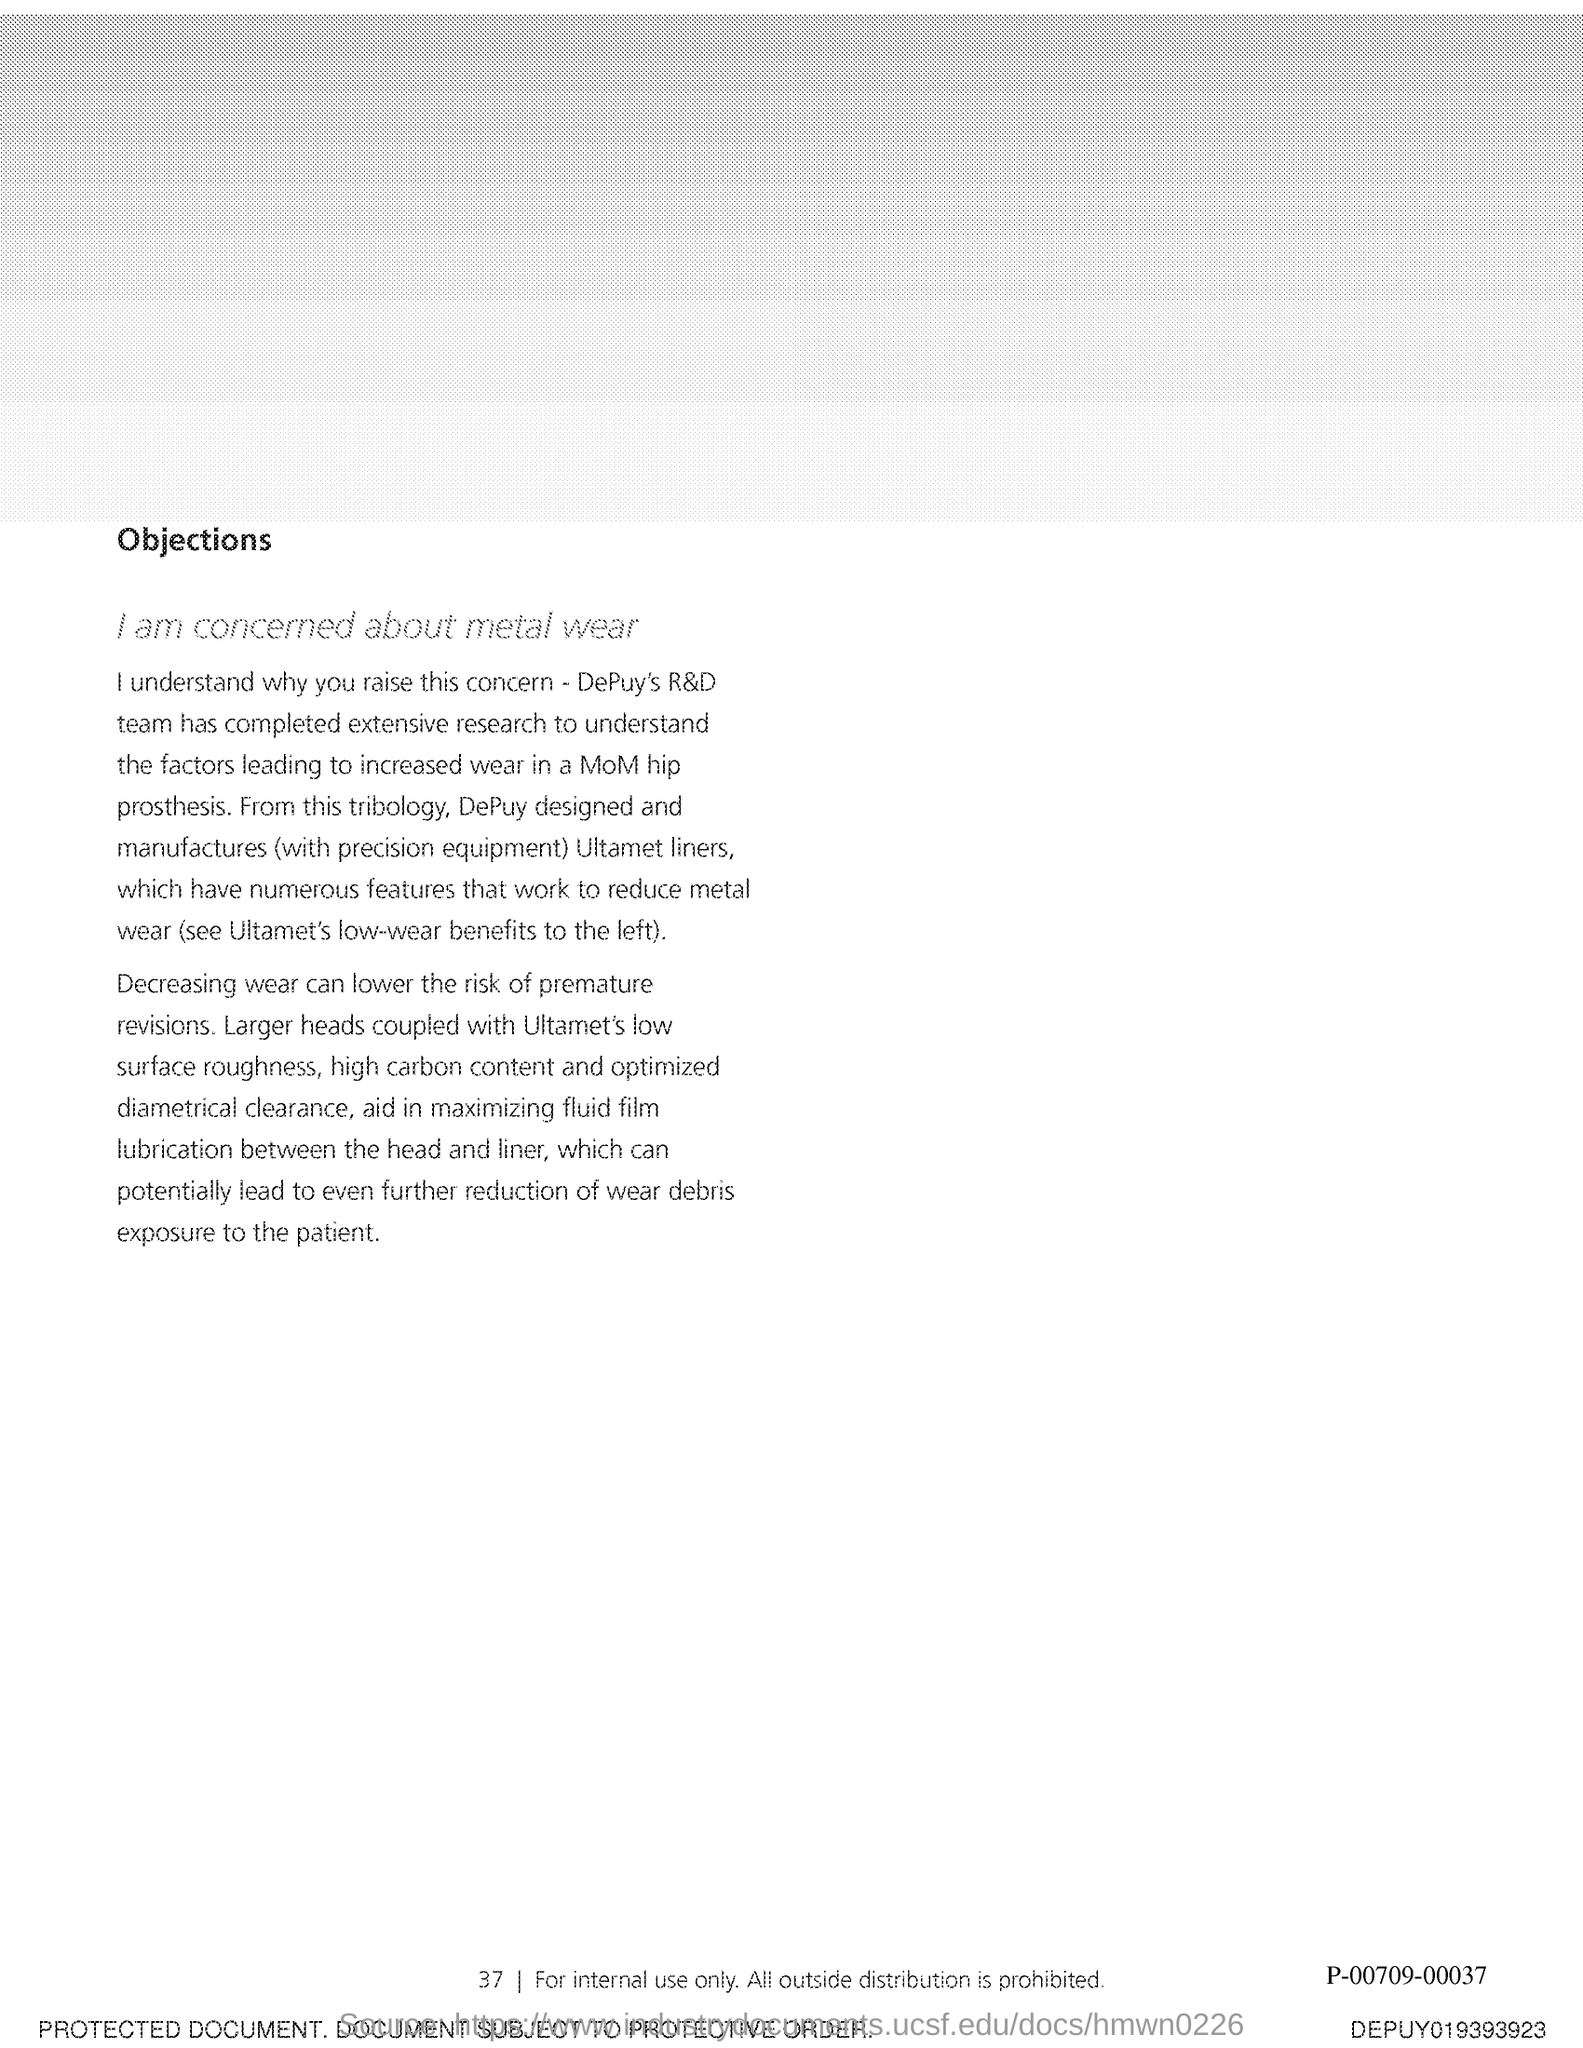What is the first title in this document?
Ensure brevity in your answer.  Objections. What is the second title in this document?
Offer a terse response. I am concerned about metal wear. 